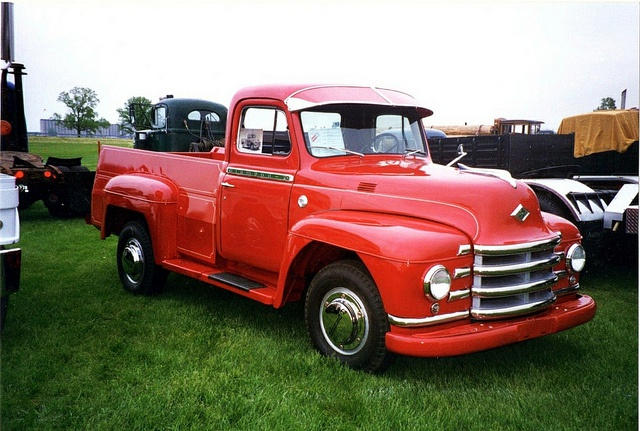Describe the objects in this image and their specific colors. I can see truck in white, black, brown, red, and salmon tones, truck in white, black, brown, tan, and gray tones, truck in white, black, gray, lightgray, and blue tones, and truck in white, black, lavender, and darkgray tones in this image. 